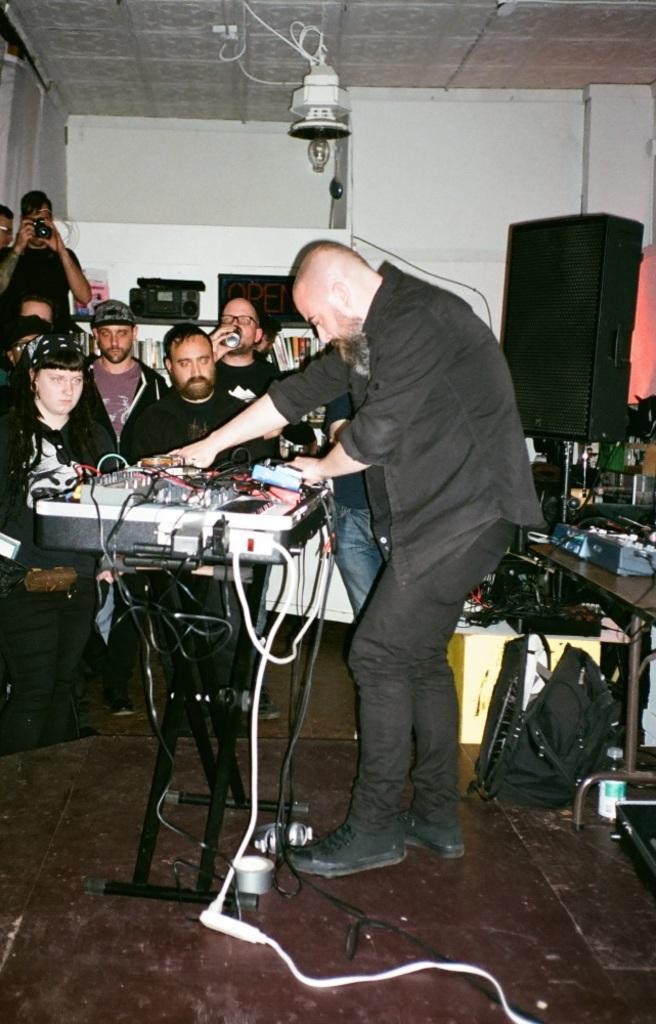Could you give a brief overview of what you see in this image? In this picture we can see the man wearing a black shirt, standing and playing the music instrument. Behind we can see some people sitting and looking to him. Behind there is a black speaker and white wall. 